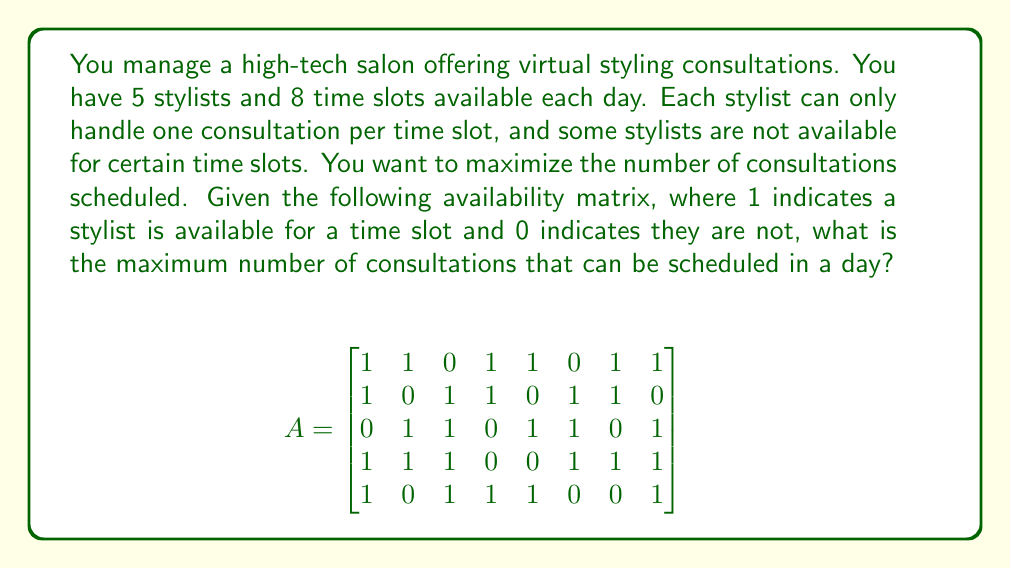Could you help me with this problem? This problem can be solved using the maximum bipartite matching algorithm, which is an application of graph theory. Here's how to approach it:

1. Construct a bipartite graph:
   - Left set: 5 nodes representing stylists
   - Right set: 8 nodes representing time slots
   - Edges: Connect a stylist node to a time slot node if the corresponding entry in matrix A is 1

2. Apply the maximum bipartite matching algorithm (e.g., Ford-Fulkerson algorithm):
   - Start with an empty matching
   - Find an augmenting path (a path that alternates between unmatched and matched edges, starting and ending with unmatched nodes)
   - Add the augmenting path to the matching
   - Repeat until no augmenting path can be found

3. The size of the maximum matching is the answer

Let's solve it step by step:

Step 1: Initial matching (e.g., greedy approach)
Stylist 1 → Time slot 1
Stylist 2 → Time slot 3
Stylist 3 → Time slot 2
Stylist 4 → Time slot 1 (conflict, skip)
Stylist 5 → Time slot 4

Current matching size: 4

Step 2: Find an augmenting path
Stylist 4 → Time slot 6 → Stylist 3 → Time slot 2 → Stylist 1 → Time slot 1

Step 3: Update matching
Stylist 1 → Time slot 1
Stylist 2 → Time slot 3
Stylist 3 → Time slot 6
Stylist 4 → Time slot 6
Stylist 5 → Time slot 4

Current matching size: 5

Step 4: No more augmenting paths can be found

Therefore, the maximum number of consultations that can be scheduled is 5.
Answer: 5 consultations 